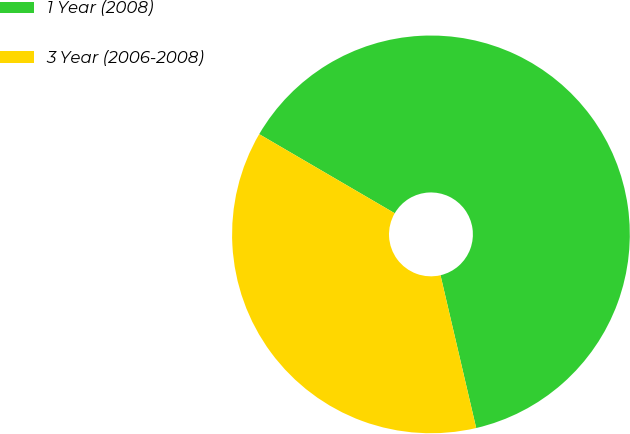Convert chart to OTSL. <chart><loc_0><loc_0><loc_500><loc_500><pie_chart><fcel>1 Year (2008)<fcel>3 Year (2006-2008)<nl><fcel>62.94%<fcel>37.06%<nl></chart> 